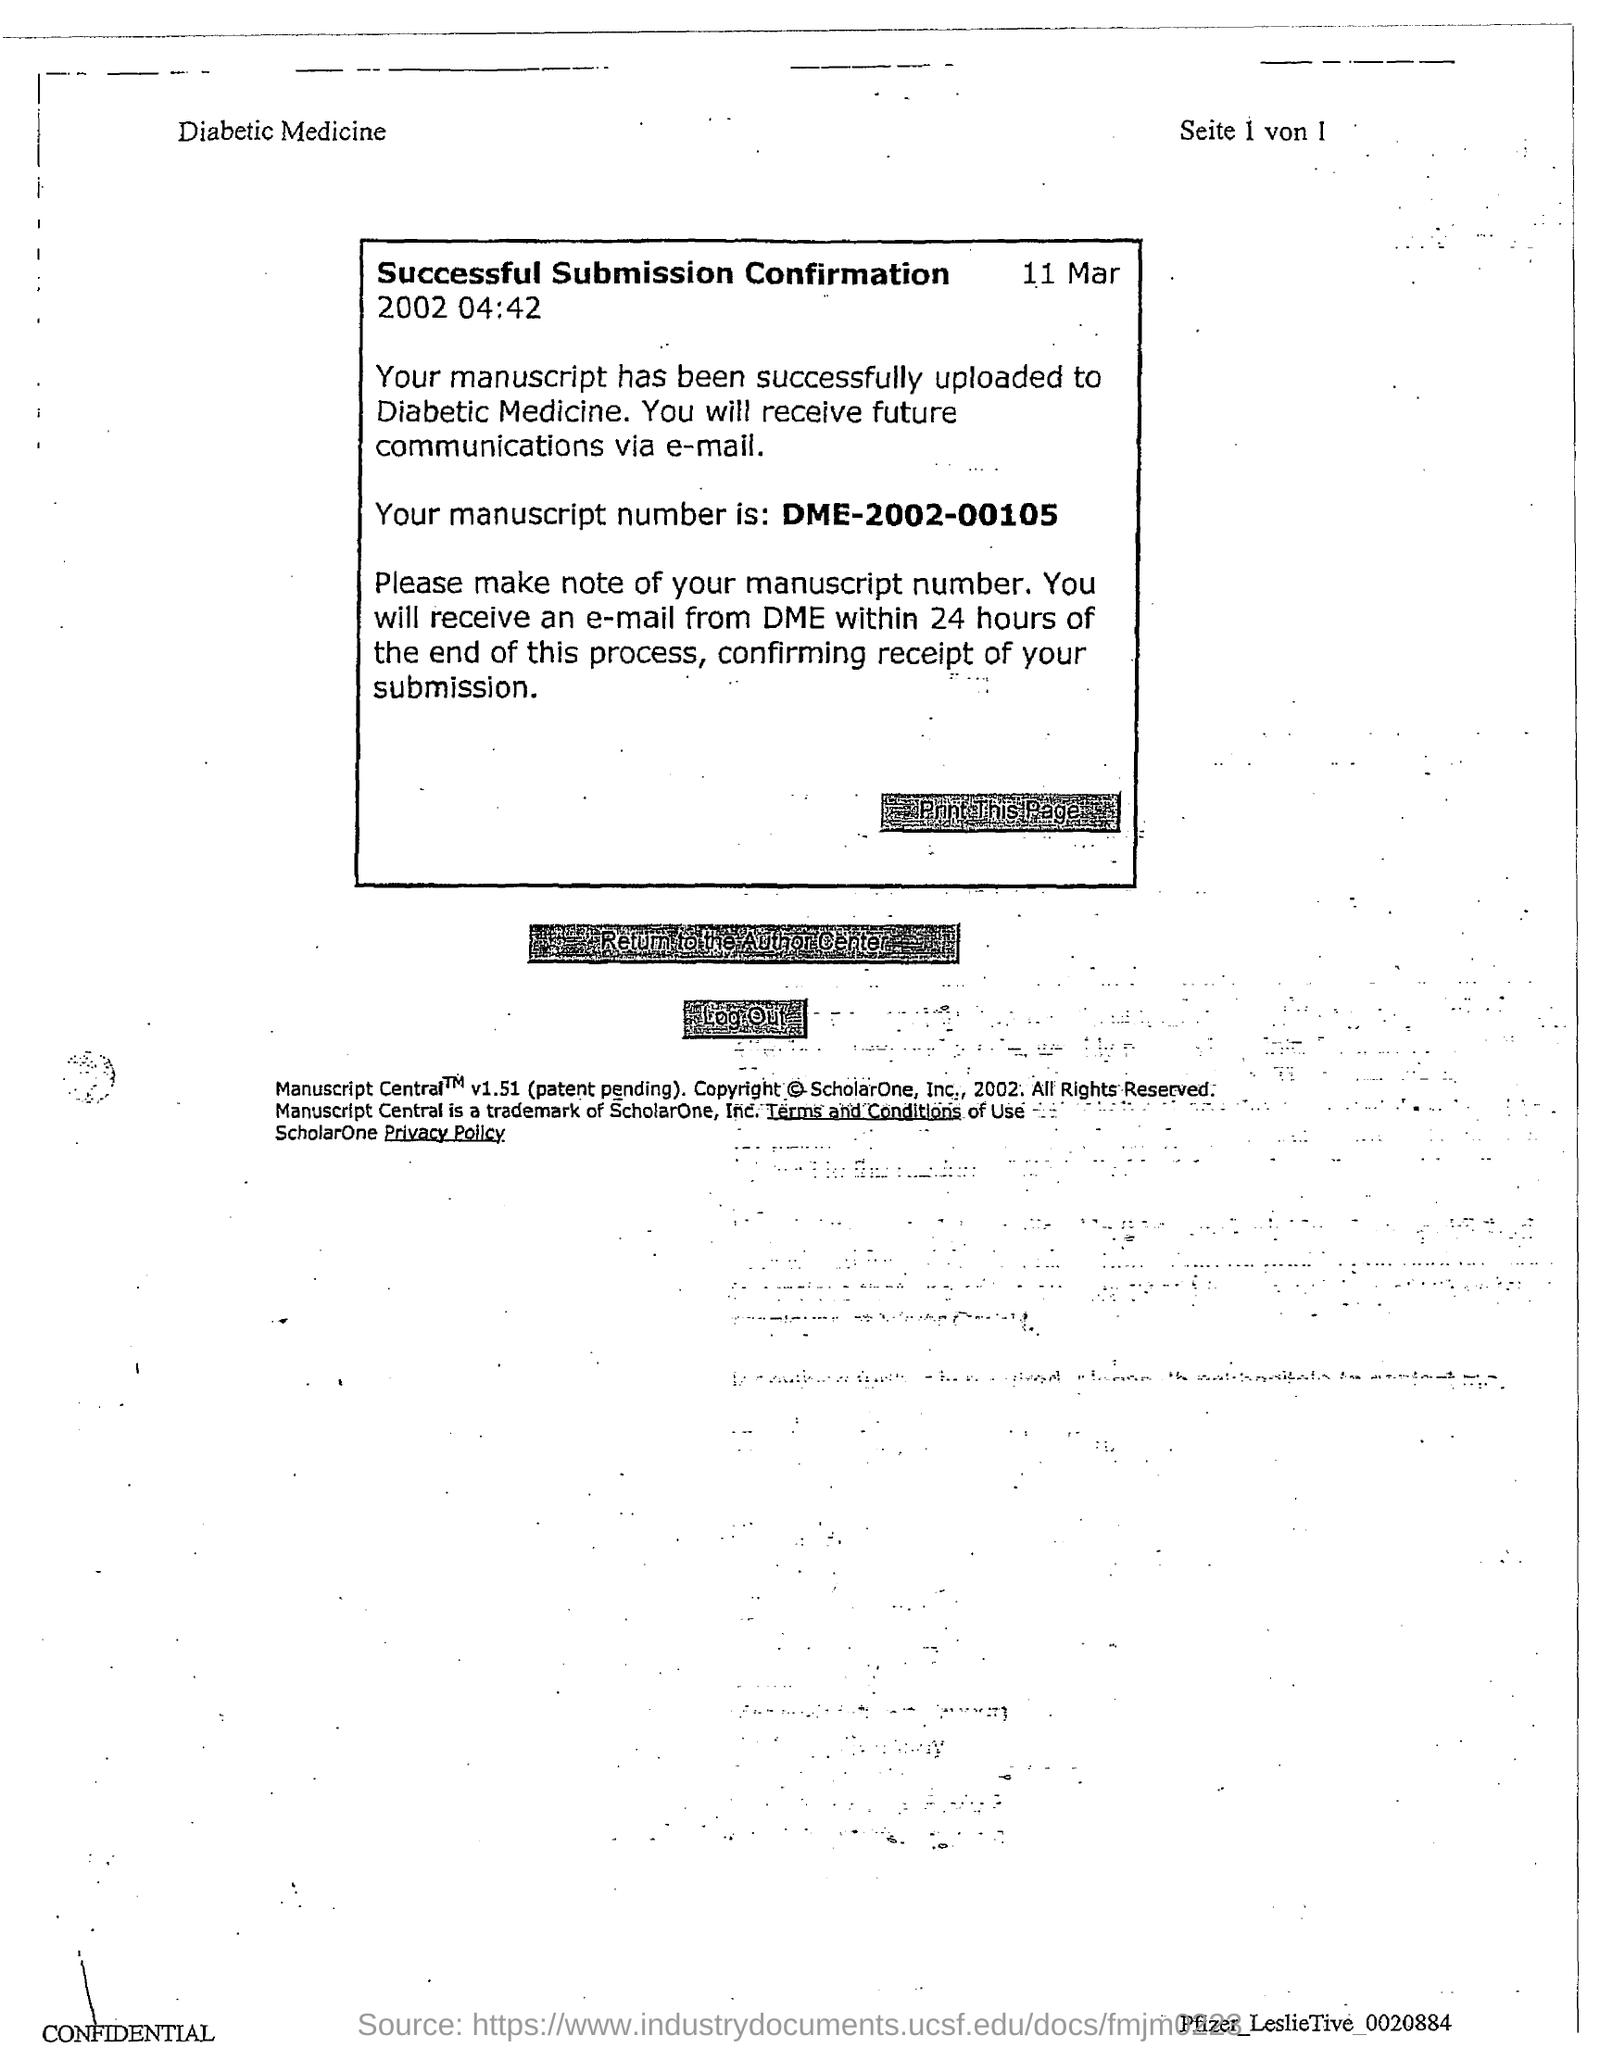What is the manuscript number mentioned in the document?
Provide a short and direct response. DME-2002-00105. What is the date & time mentioned in this document?
Keep it short and to the point. 11 Mar 2002 04:42. 